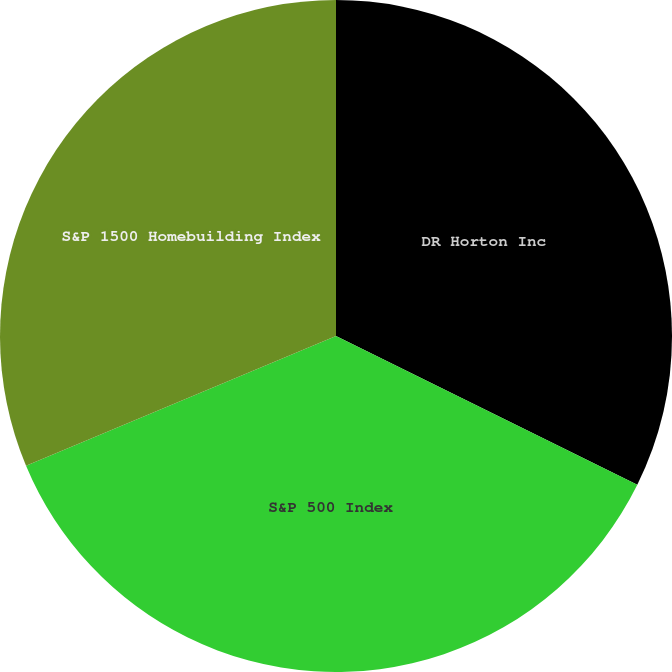Convert chart. <chart><loc_0><loc_0><loc_500><loc_500><pie_chart><fcel>DR Horton Inc<fcel>S&P 500 Index<fcel>S&P 1500 Homebuilding Index<nl><fcel>32.3%<fcel>36.4%<fcel>31.31%<nl></chart> 